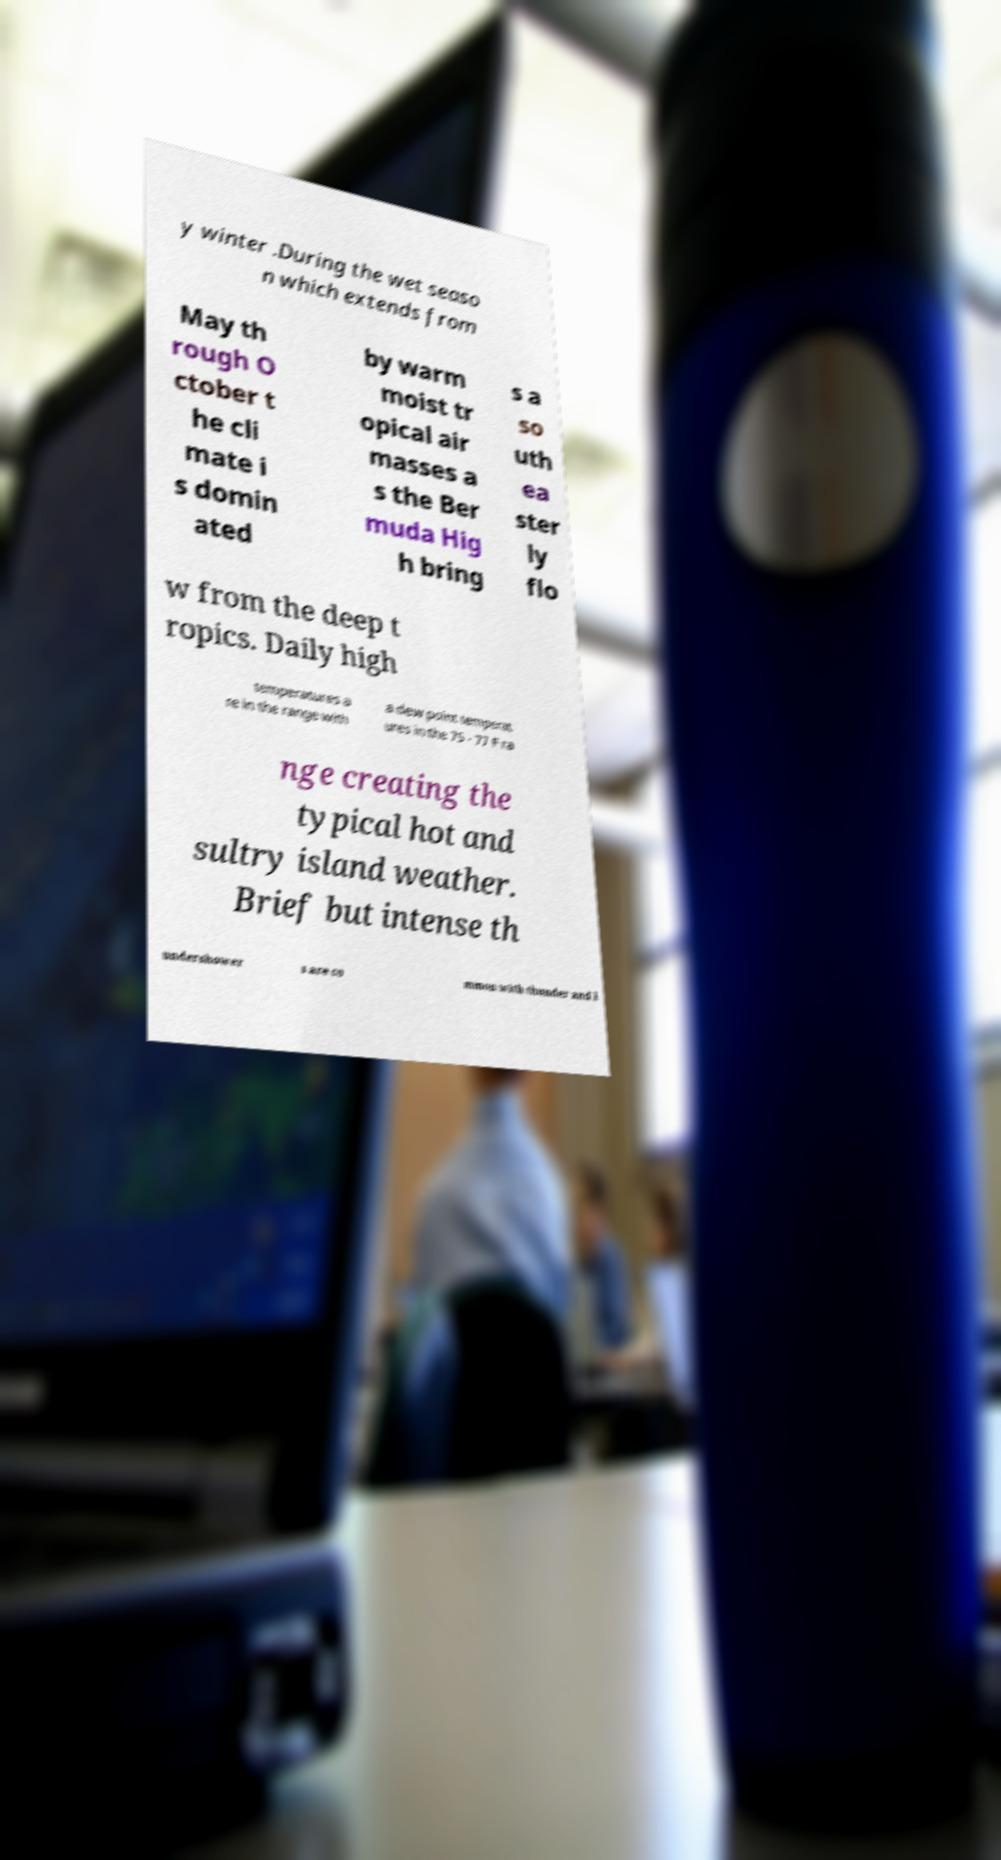Please identify and transcribe the text found in this image. y winter .During the wet seaso n which extends from May th rough O ctober t he cli mate i s domin ated by warm moist tr opical air masses a s the Ber muda Hig h bring s a so uth ea ster ly flo w from the deep t ropics. Daily high temperatures a re in the range with a dew point temperat ures in the 75 - 77 F ra nge creating the typical hot and sultry island weather. Brief but intense th undershower s are co mmon with thunder and l 